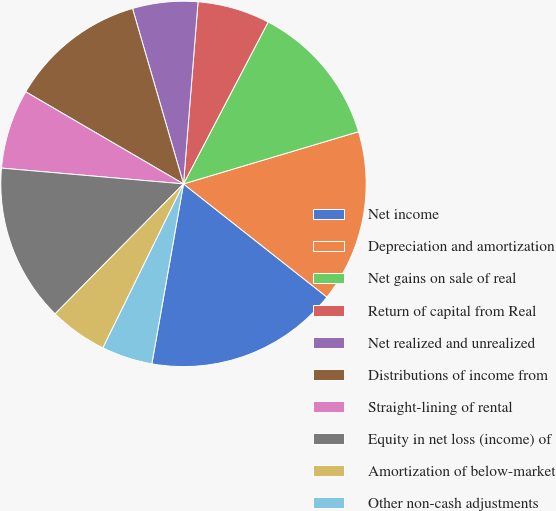Convert chart. <chart><loc_0><loc_0><loc_500><loc_500><pie_chart><fcel>Net income<fcel>Depreciation and amortization<fcel>Net gains on sale of real<fcel>Return of capital from Real<fcel>Net realized and unrealized<fcel>Distributions of income from<fcel>Straight-lining of rental<fcel>Equity in net loss (income) of<fcel>Amortization of below-market<fcel>Other non-cash adjustments<nl><fcel>17.14%<fcel>15.25%<fcel>12.72%<fcel>6.4%<fcel>5.77%<fcel>12.09%<fcel>7.03%<fcel>13.98%<fcel>5.13%<fcel>4.5%<nl></chart> 